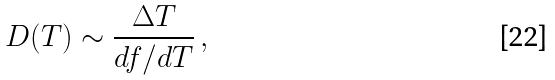<formula> <loc_0><loc_0><loc_500><loc_500>D ( T ) \sim \frac { \Delta T } { d f / d T } \, ,</formula> 